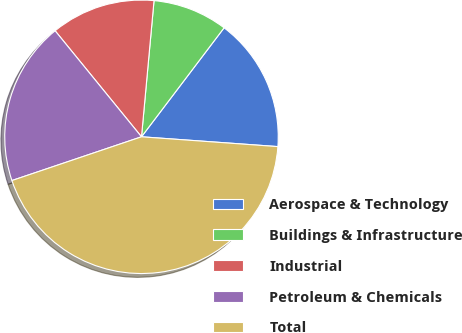Convert chart to OTSL. <chart><loc_0><loc_0><loc_500><loc_500><pie_chart><fcel>Aerospace & Technology<fcel>Buildings & Infrastructure<fcel>Industrial<fcel>Petroleum & Chemicals<fcel>Total<nl><fcel>15.82%<fcel>8.86%<fcel>12.34%<fcel>19.3%<fcel>43.67%<nl></chart> 